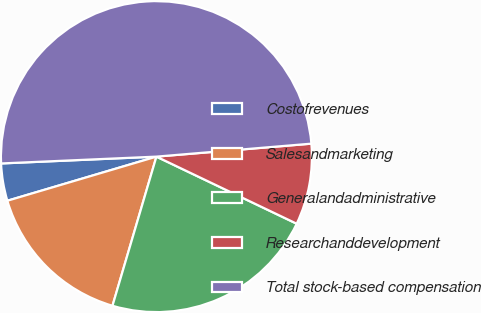<chart> <loc_0><loc_0><loc_500><loc_500><pie_chart><fcel>Costofrevenues<fcel>Salesandmarketing<fcel>Generalandadministrative<fcel>Researchanddevelopment<fcel>Total stock-based compensation<nl><fcel>3.88%<fcel>15.86%<fcel>22.46%<fcel>8.43%<fcel>49.37%<nl></chart> 